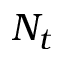<formula> <loc_0><loc_0><loc_500><loc_500>N _ { t }</formula> 